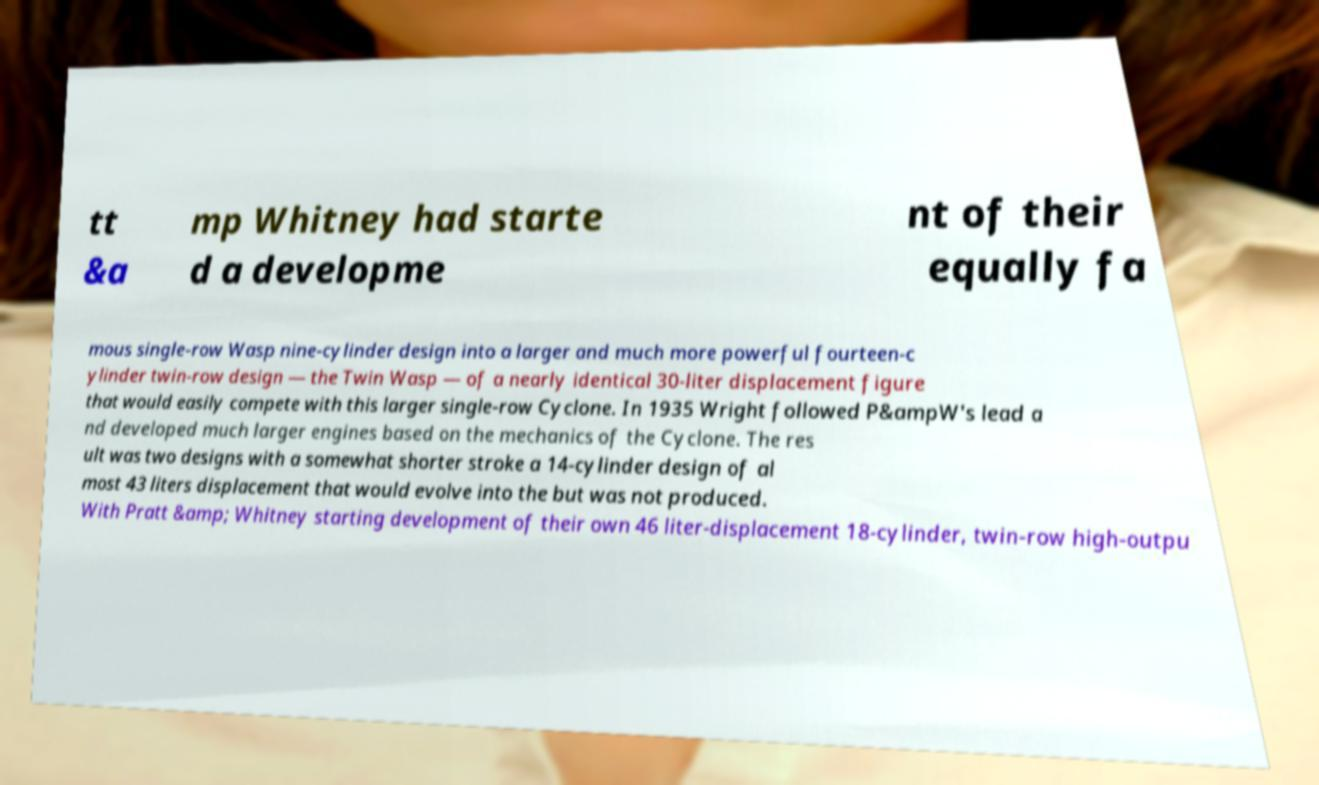I need the written content from this picture converted into text. Can you do that? tt &a mp Whitney had starte d a developme nt of their equally fa mous single-row Wasp nine-cylinder design into a larger and much more powerful fourteen-c ylinder twin-row design — the Twin Wasp — of a nearly identical 30-liter displacement figure that would easily compete with this larger single-row Cyclone. In 1935 Wright followed P&ampW's lead a nd developed much larger engines based on the mechanics of the Cyclone. The res ult was two designs with a somewhat shorter stroke a 14-cylinder design of al most 43 liters displacement that would evolve into the but was not produced. With Pratt &amp; Whitney starting development of their own 46 liter-displacement 18-cylinder, twin-row high-outpu 